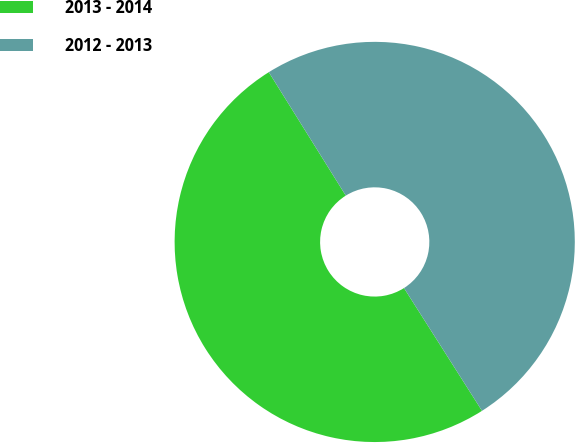Convert chart. <chart><loc_0><loc_0><loc_500><loc_500><pie_chart><fcel>2013 - 2014<fcel>2012 - 2013<nl><fcel>50.13%<fcel>49.87%<nl></chart> 